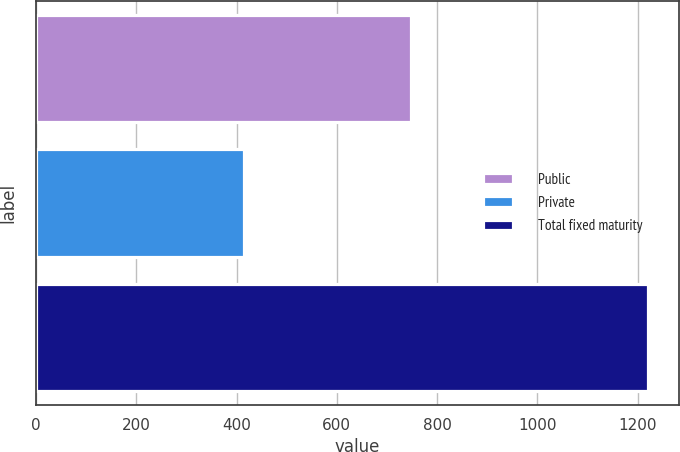Convert chart. <chart><loc_0><loc_0><loc_500><loc_500><bar_chart><fcel>Public<fcel>Private<fcel>Total fixed maturity<nl><fcel>747.4<fcel>415.7<fcel>1221.3<nl></chart> 